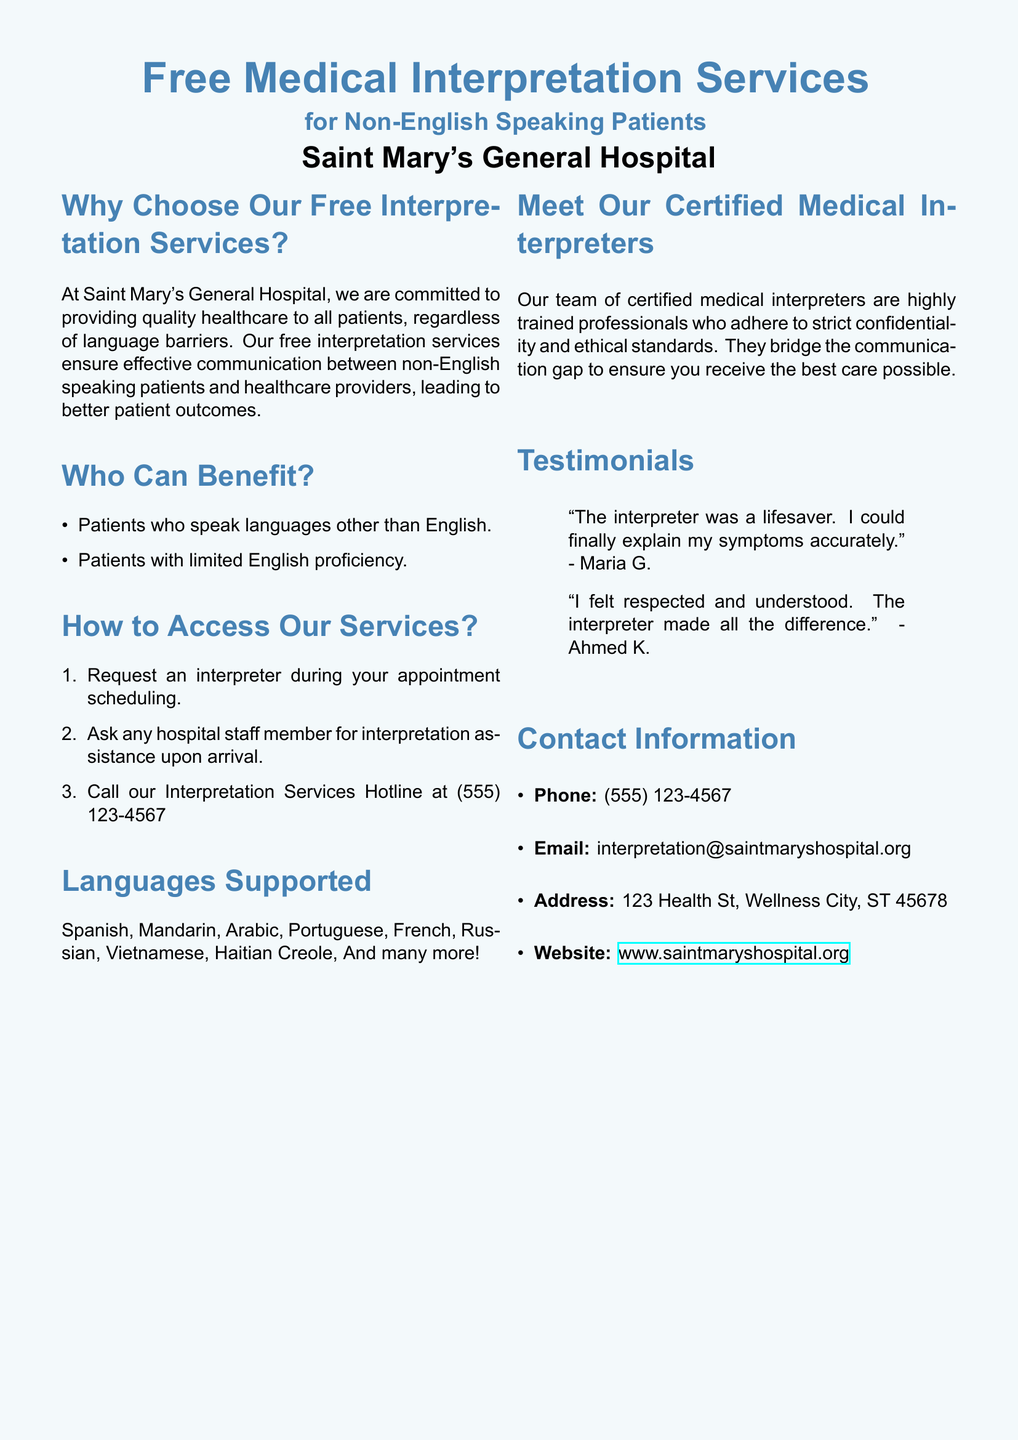What is the name of the hospital offering these services? The document states that the services are offered by Saint Mary's General Hospital.
Answer: Saint Mary's General Hospital How can patients request an interpreter? The document lists several ways to request an interpreter, including during appointment scheduling and asking hospital staff.
Answer: During appointment scheduling Which telephone number is provided for the Interpretation Services Hotline? The hotline phone number for interpretation services is specified in the contact information section of the document.
Answer: (555) 123-4567 What is the email address to contact for interpretation services? The email address provided in the contact information section is relevant for reaching the interpretation services.
Answer: interpretation@saintmaryshospital.org Which language is NOT listed among the supported languages? The document includes a list of supported languages, and any language not mentioned can be referenced here.
Answer: (any language not mentioned) Why are certified medical interpreters essential? The document explains that certified medical interpreters bridge communication gaps to ensure quality care.
Answer: To ensure quality care What is a benefit mentioned for using the interpretation service? The document highlights that the service ensures effective communication between patients and healthcare providers.
Answer: Effective communication How many testimonials are included in the document? The document includes a section with testimonials from two individuals sharing their experiences.
Answer: Two What type of document is this? The nature of the document (a flyer) is confirmed by its purpose and the information it presents about services.
Answer: Flyer 